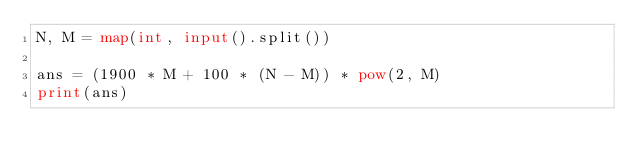Convert code to text. <code><loc_0><loc_0><loc_500><loc_500><_Python_>N, M = map(int, input().split())

ans = (1900 * M + 100 * (N - M)) * pow(2, M)
print(ans)
</code> 